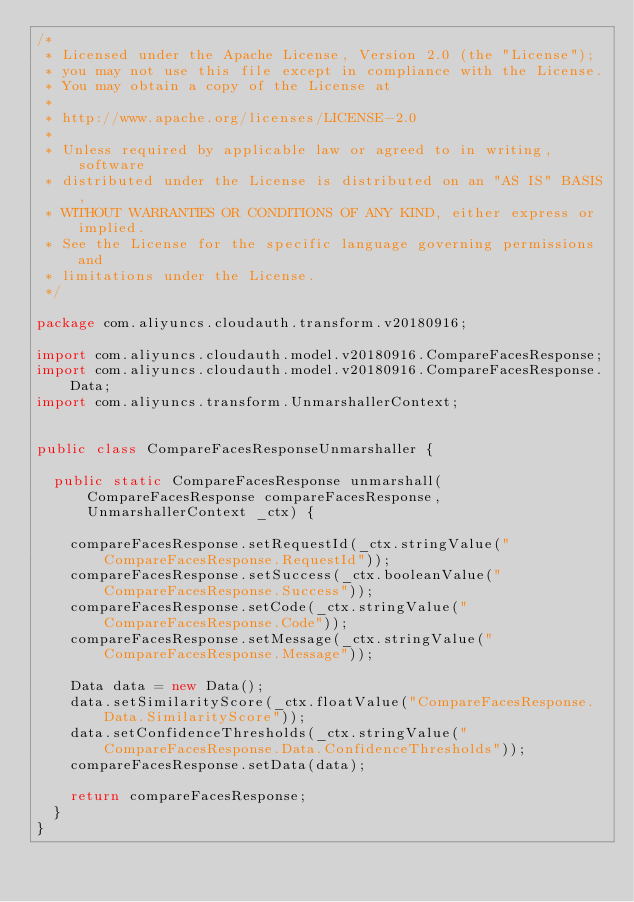<code> <loc_0><loc_0><loc_500><loc_500><_Java_>/*
 * Licensed under the Apache License, Version 2.0 (the "License");
 * you may not use this file except in compliance with the License.
 * You may obtain a copy of the License at
 *
 * http://www.apache.org/licenses/LICENSE-2.0
 *
 * Unless required by applicable law or agreed to in writing, software
 * distributed under the License is distributed on an "AS IS" BASIS,
 * WITHOUT WARRANTIES OR CONDITIONS OF ANY KIND, either express or implied.
 * See the License for the specific language governing permissions and
 * limitations under the License.
 */

package com.aliyuncs.cloudauth.transform.v20180916;

import com.aliyuncs.cloudauth.model.v20180916.CompareFacesResponse;
import com.aliyuncs.cloudauth.model.v20180916.CompareFacesResponse.Data;
import com.aliyuncs.transform.UnmarshallerContext;


public class CompareFacesResponseUnmarshaller {

	public static CompareFacesResponse unmarshall(CompareFacesResponse compareFacesResponse, UnmarshallerContext _ctx) {
		
		compareFacesResponse.setRequestId(_ctx.stringValue("CompareFacesResponse.RequestId"));
		compareFacesResponse.setSuccess(_ctx.booleanValue("CompareFacesResponse.Success"));
		compareFacesResponse.setCode(_ctx.stringValue("CompareFacesResponse.Code"));
		compareFacesResponse.setMessage(_ctx.stringValue("CompareFacesResponse.Message"));

		Data data = new Data();
		data.setSimilarityScore(_ctx.floatValue("CompareFacesResponse.Data.SimilarityScore"));
		data.setConfidenceThresholds(_ctx.stringValue("CompareFacesResponse.Data.ConfidenceThresholds"));
		compareFacesResponse.setData(data);
	 
	 	return compareFacesResponse;
	}
}</code> 